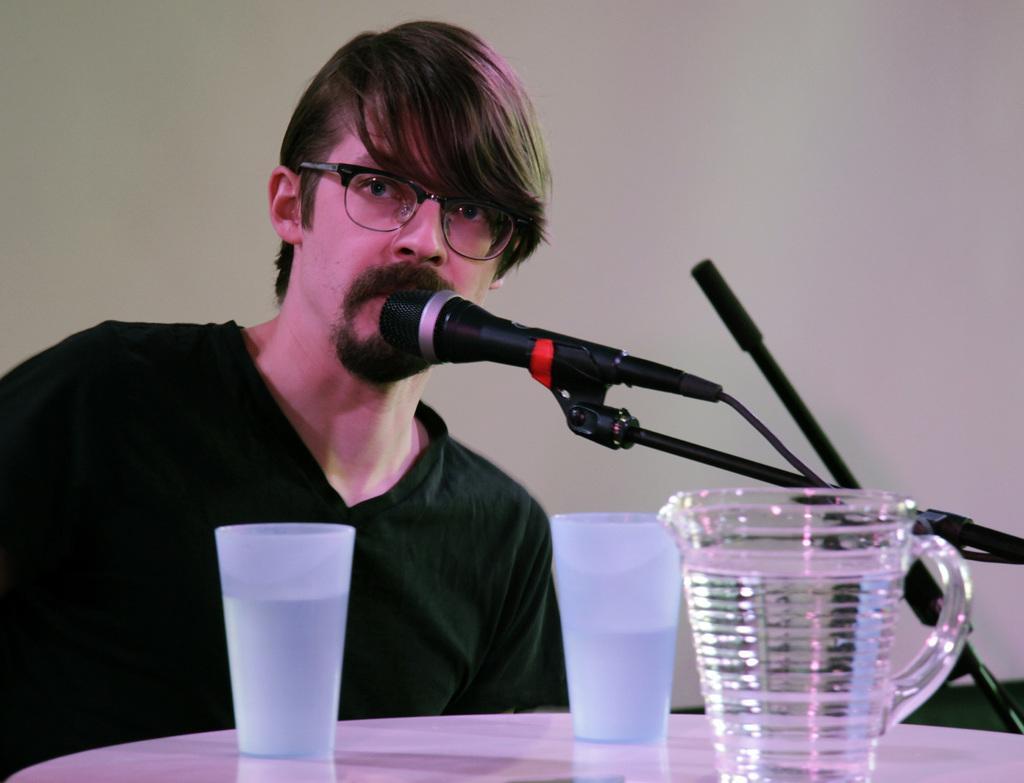Please provide a concise description of this image. In this picture we can see a man, he wore spectacles, in front of him we can see few glasses, jug and a microphone, and he wore a black color t-shirt. 